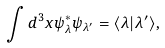<formula> <loc_0><loc_0><loc_500><loc_500>\int d ^ { 3 } x \psi _ { \lambda } ^ { * } \psi _ { \lambda ^ { \prime } } = \langle \lambda | \lambda ^ { \prime } \rangle ,</formula> 